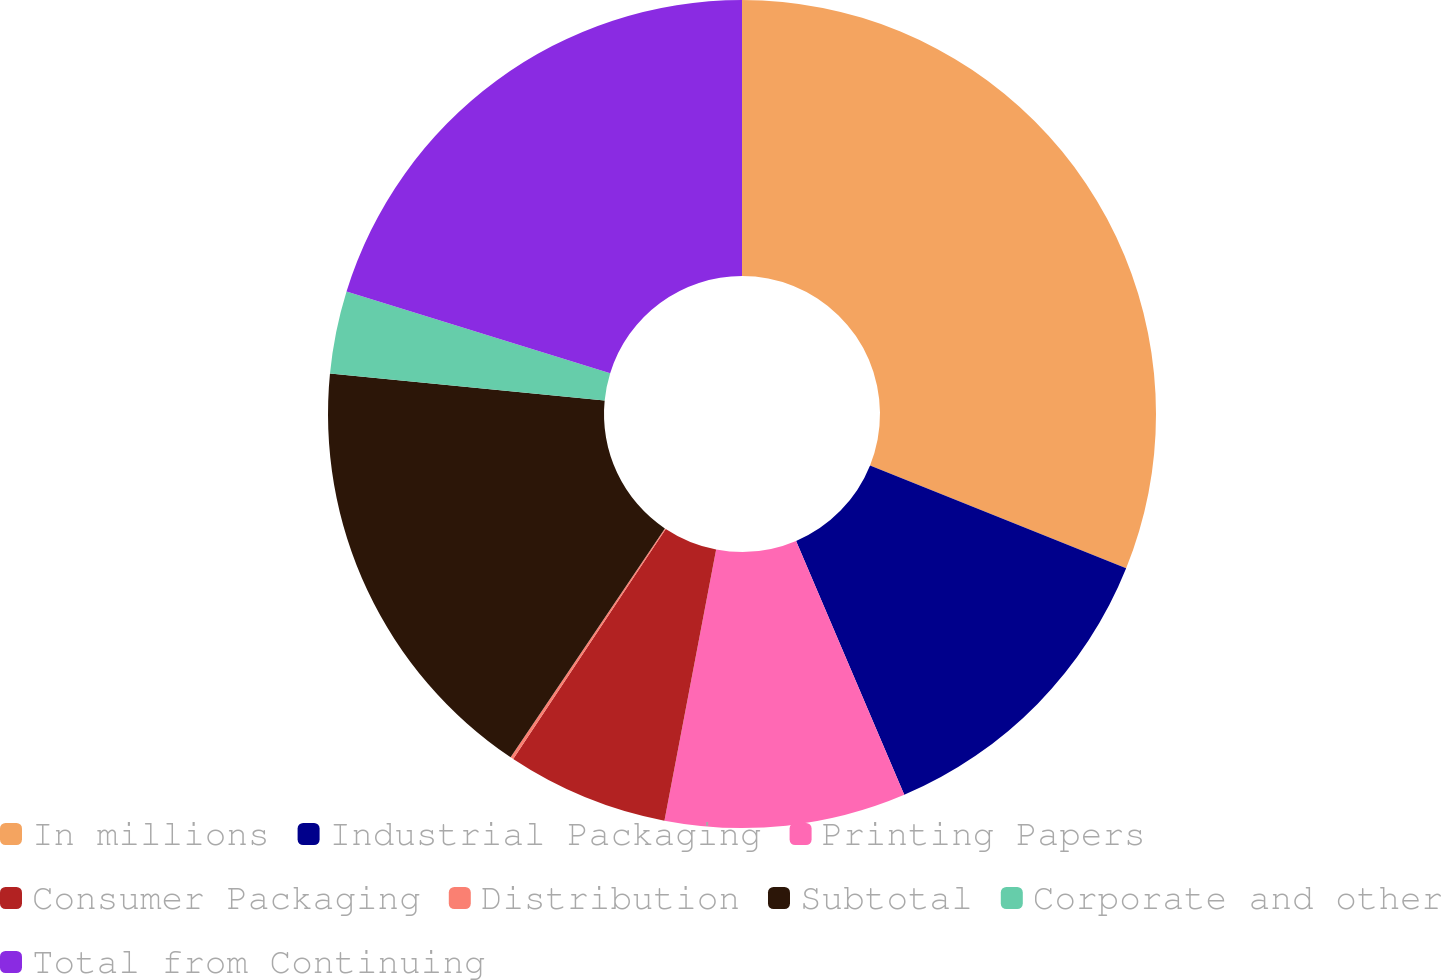<chart> <loc_0><loc_0><loc_500><loc_500><pie_chart><fcel>In millions<fcel>Industrial Packaging<fcel>Printing Papers<fcel>Consumer Packaging<fcel>Distribution<fcel>Subtotal<fcel>Corporate and other<fcel>Total from Continuing<nl><fcel>31.08%<fcel>12.51%<fcel>9.41%<fcel>6.32%<fcel>0.12%<fcel>17.12%<fcel>3.22%<fcel>20.22%<nl></chart> 